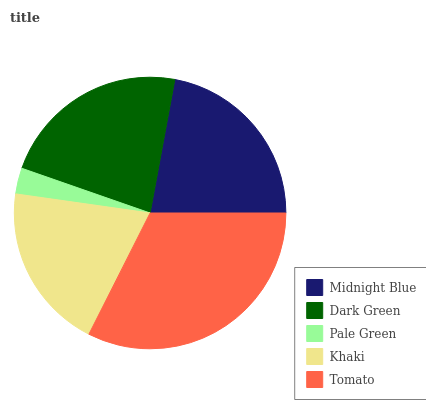Is Pale Green the minimum?
Answer yes or no. Yes. Is Tomato the maximum?
Answer yes or no. Yes. Is Dark Green the minimum?
Answer yes or no. No. Is Dark Green the maximum?
Answer yes or no. No. Is Dark Green greater than Midnight Blue?
Answer yes or no. Yes. Is Midnight Blue less than Dark Green?
Answer yes or no. Yes. Is Midnight Blue greater than Dark Green?
Answer yes or no. No. Is Dark Green less than Midnight Blue?
Answer yes or no. No. Is Midnight Blue the high median?
Answer yes or no. Yes. Is Midnight Blue the low median?
Answer yes or no. Yes. Is Pale Green the high median?
Answer yes or no. No. Is Tomato the low median?
Answer yes or no. No. 